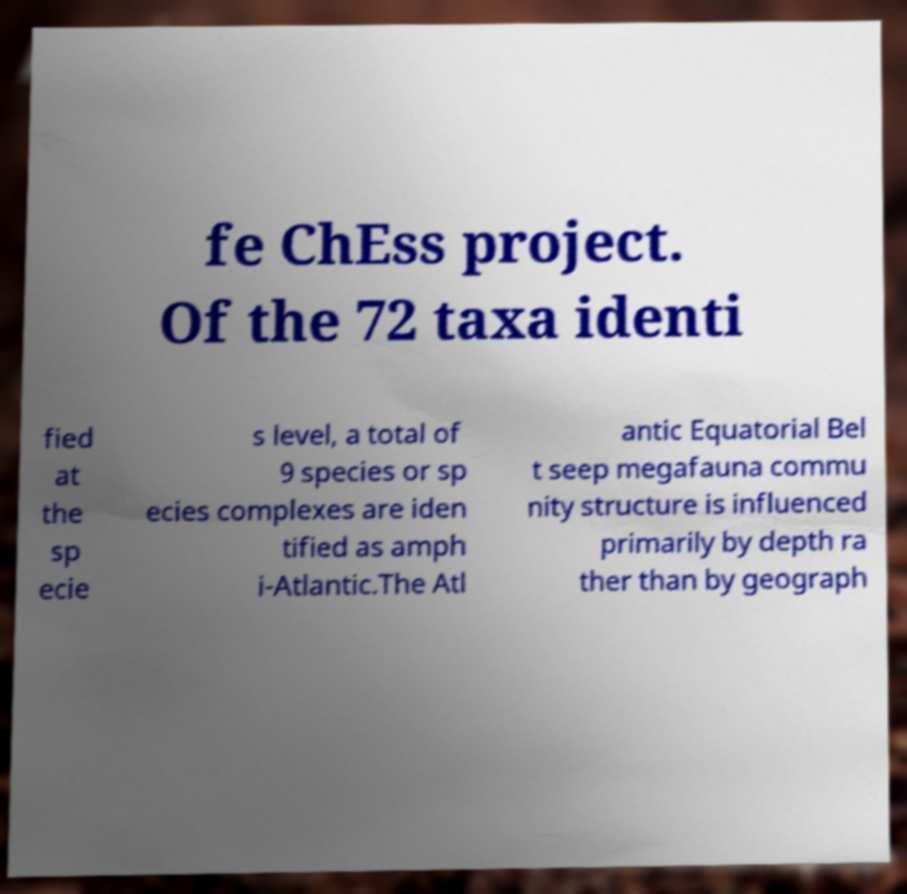Can you read and provide the text displayed in the image?This photo seems to have some interesting text. Can you extract and type it out for me? fe ChEss project. Of the 72 taxa identi fied at the sp ecie s level, a total of 9 species or sp ecies complexes are iden tified as amph i-Atlantic.The Atl antic Equatorial Bel t seep megafauna commu nity structure is influenced primarily by depth ra ther than by geograph 